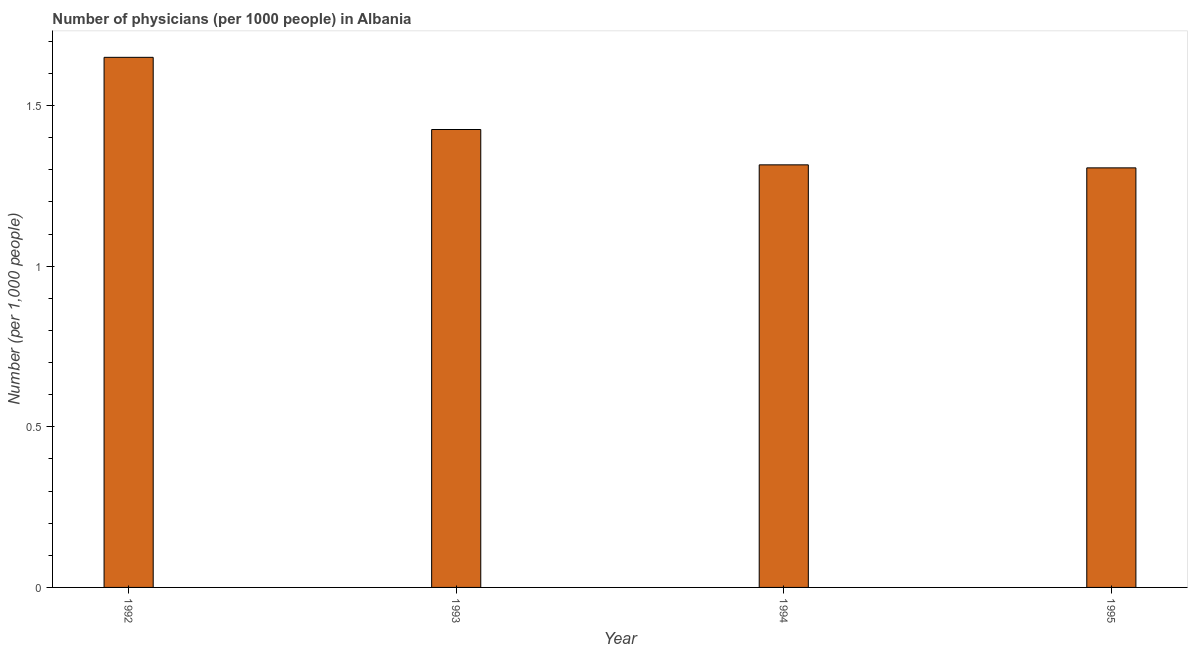What is the title of the graph?
Your response must be concise. Number of physicians (per 1000 people) in Albania. What is the label or title of the X-axis?
Your answer should be compact. Year. What is the label or title of the Y-axis?
Your answer should be very brief. Number (per 1,0 people). What is the number of physicians in 1994?
Give a very brief answer. 1.32. Across all years, what is the maximum number of physicians?
Your response must be concise. 1.65. Across all years, what is the minimum number of physicians?
Give a very brief answer. 1.31. In which year was the number of physicians maximum?
Your answer should be very brief. 1992. In which year was the number of physicians minimum?
Provide a short and direct response. 1995. What is the sum of the number of physicians?
Keep it short and to the point. 5.7. What is the difference between the number of physicians in 1993 and 1994?
Offer a very short reply. 0.11. What is the average number of physicians per year?
Provide a short and direct response. 1.42. What is the median number of physicians?
Provide a succinct answer. 1.37. Do a majority of the years between 1995 and 1994 (inclusive) have number of physicians greater than 1 ?
Make the answer very short. No. What is the ratio of the number of physicians in 1992 to that in 1994?
Your answer should be compact. 1.25. What is the difference between the highest and the second highest number of physicians?
Your answer should be very brief. 0.23. Is the sum of the number of physicians in 1992 and 1993 greater than the maximum number of physicians across all years?
Keep it short and to the point. Yes. What is the difference between the highest and the lowest number of physicians?
Offer a very short reply. 0.34. In how many years, is the number of physicians greater than the average number of physicians taken over all years?
Your answer should be compact. 2. Are all the bars in the graph horizontal?
Ensure brevity in your answer.  No. How many years are there in the graph?
Provide a succinct answer. 4. What is the difference between two consecutive major ticks on the Y-axis?
Offer a very short reply. 0.5. Are the values on the major ticks of Y-axis written in scientific E-notation?
Offer a very short reply. No. What is the Number (per 1,000 people) of 1992?
Keep it short and to the point. 1.65. What is the Number (per 1,000 people) of 1993?
Make the answer very short. 1.43. What is the Number (per 1,000 people) of 1994?
Your answer should be very brief. 1.32. What is the Number (per 1,000 people) of 1995?
Provide a succinct answer. 1.31. What is the difference between the Number (per 1,000 people) in 1992 and 1993?
Offer a terse response. 0.22. What is the difference between the Number (per 1,000 people) in 1992 and 1994?
Provide a succinct answer. 0.33. What is the difference between the Number (per 1,000 people) in 1992 and 1995?
Keep it short and to the point. 0.34. What is the difference between the Number (per 1,000 people) in 1993 and 1994?
Your response must be concise. 0.11. What is the difference between the Number (per 1,000 people) in 1993 and 1995?
Your answer should be very brief. 0.12. What is the difference between the Number (per 1,000 people) in 1994 and 1995?
Offer a terse response. 0.01. What is the ratio of the Number (per 1,000 people) in 1992 to that in 1993?
Ensure brevity in your answer.  1.16. What is the ratio of the Number (per 1,000 people) in 1992 to that in 1994?
Ensure brevity in your answer.  1.25. What is the ratio of the Number (per 1,000 people) in 1992 to that in 1995?
Offer a very short reply. 1.26. What is the ratio of the Number (per 1,000 people) in 1993 to that in 1994?
Provide a short and direct response. 1.08. What is the ratio of the Number (per 1,000 people) in 1993 to that in 1995?
Give a very brief answer. 1.09. 